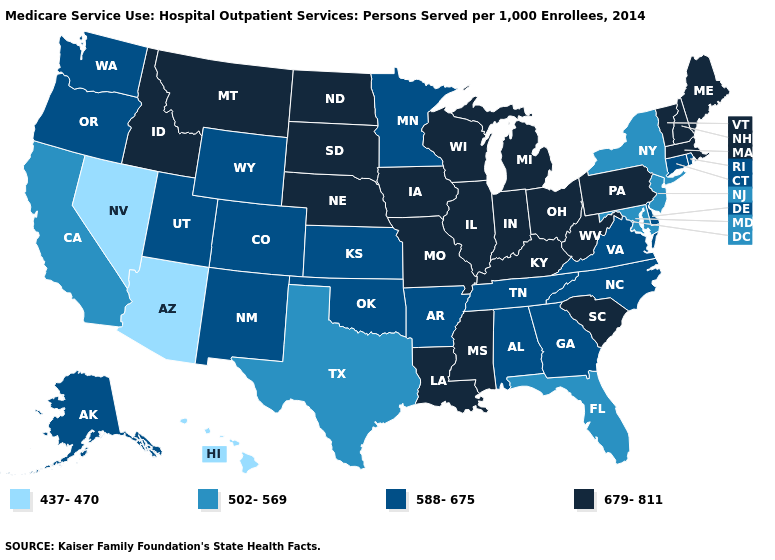What is the value of Utah?
Write a very short answer. 588-675. What is the value of Minnesota?
Be succinct. 588-675. Name the states that have a value in the range 437-470?
Give a very brief answer. Arizona, Hawaii, Nevada. Is the legend a continuous bar?
Be succinct. No. What is the value of Ohio?
Keep it brief. 679-811. Does Delaware have the same value as Maryland?
Write a very short answer. No. Does the first symbol in the legend represent the smallest category?
Quick response, please. Yes. What is the highest value in the USA?
Concise answer only. 679-811. What is the lowest value in the USA?
Give a very brief answer. 437-470. What is the lowest value in states that border Wyoming?
Concise answer only. 588-675. Does Massachusetts have the highest value in the USA?
Answer briefly. Yes. Name the states that have a value in the range 679-811?
Give a very brief answer. Idaho, Illinois, Indiana, Iowa, Kentucky, Louisiana, Maine, Massachusetts, Michigan, Mississippi, Missouri, Montana, Nebraska, New Hampshire, North Dakota, Ohio, Pennsylvania, South Carolina, South Dakota, Vermont, West Virginia, Wisconsin. Does the first symbol in the legend represent the smallest category?
Answer briefly. Yes. What is the highest value in the South ?
Write a very short answer. 679-811. 